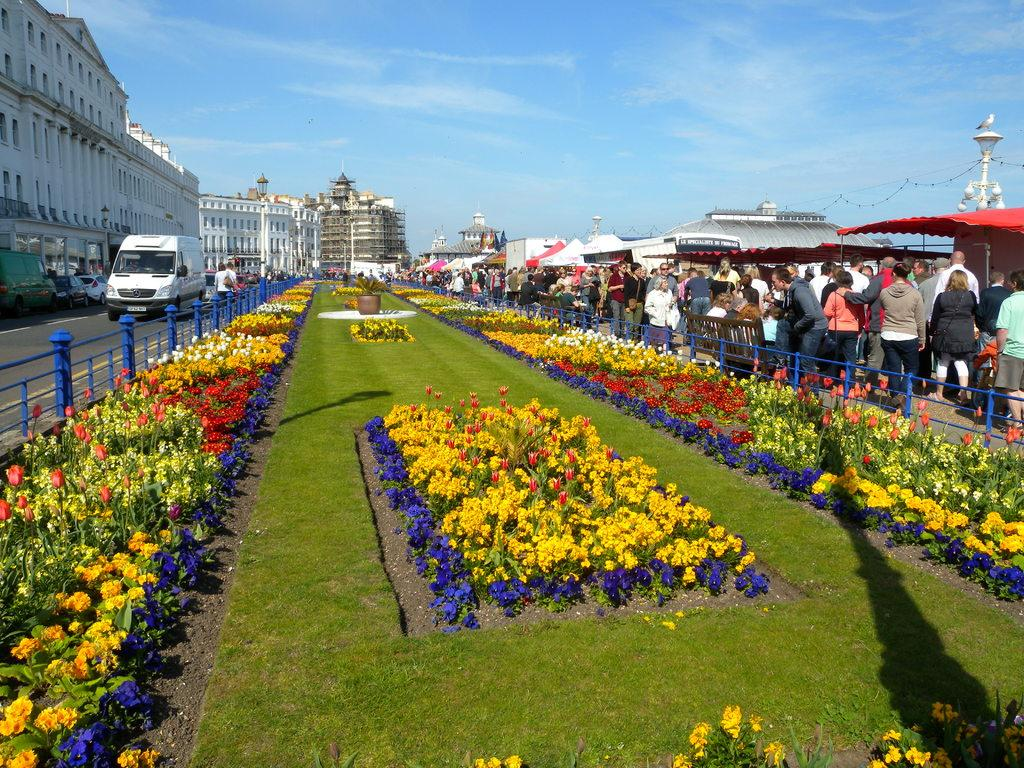What type of plants can be seen in the image? There are flowers in the image. What else is present in the image besides the flowers? There are people standing and a white van on the road visible in the image. What type of structures can be seen in the image? There are buildings visible in the image. What is the color of the sky in the image? The sky is blue at the top of the image. What type of grain is being harvested in the image? There is no grain present in the image; it features flowers, people, a white van, buildings, and a blue sky. 